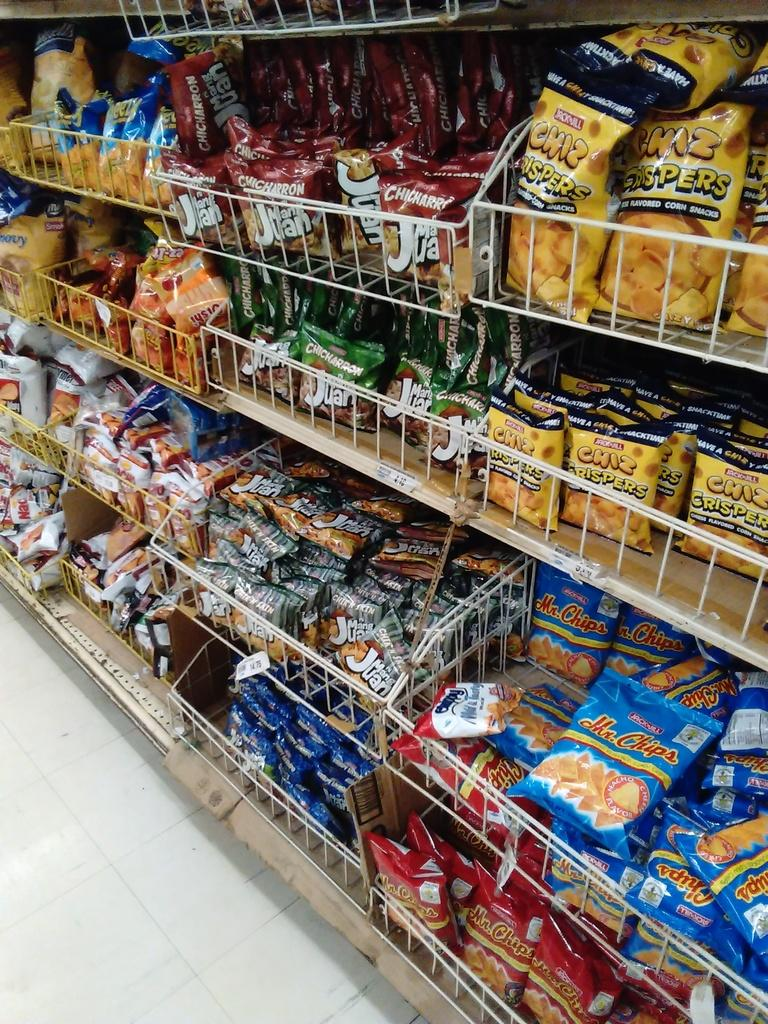Provide a one-sentence caption for the provided image. The snack aisle of a store is fully stocked with Chiz Crispers, Chicharron's, and several other salty snacks. 